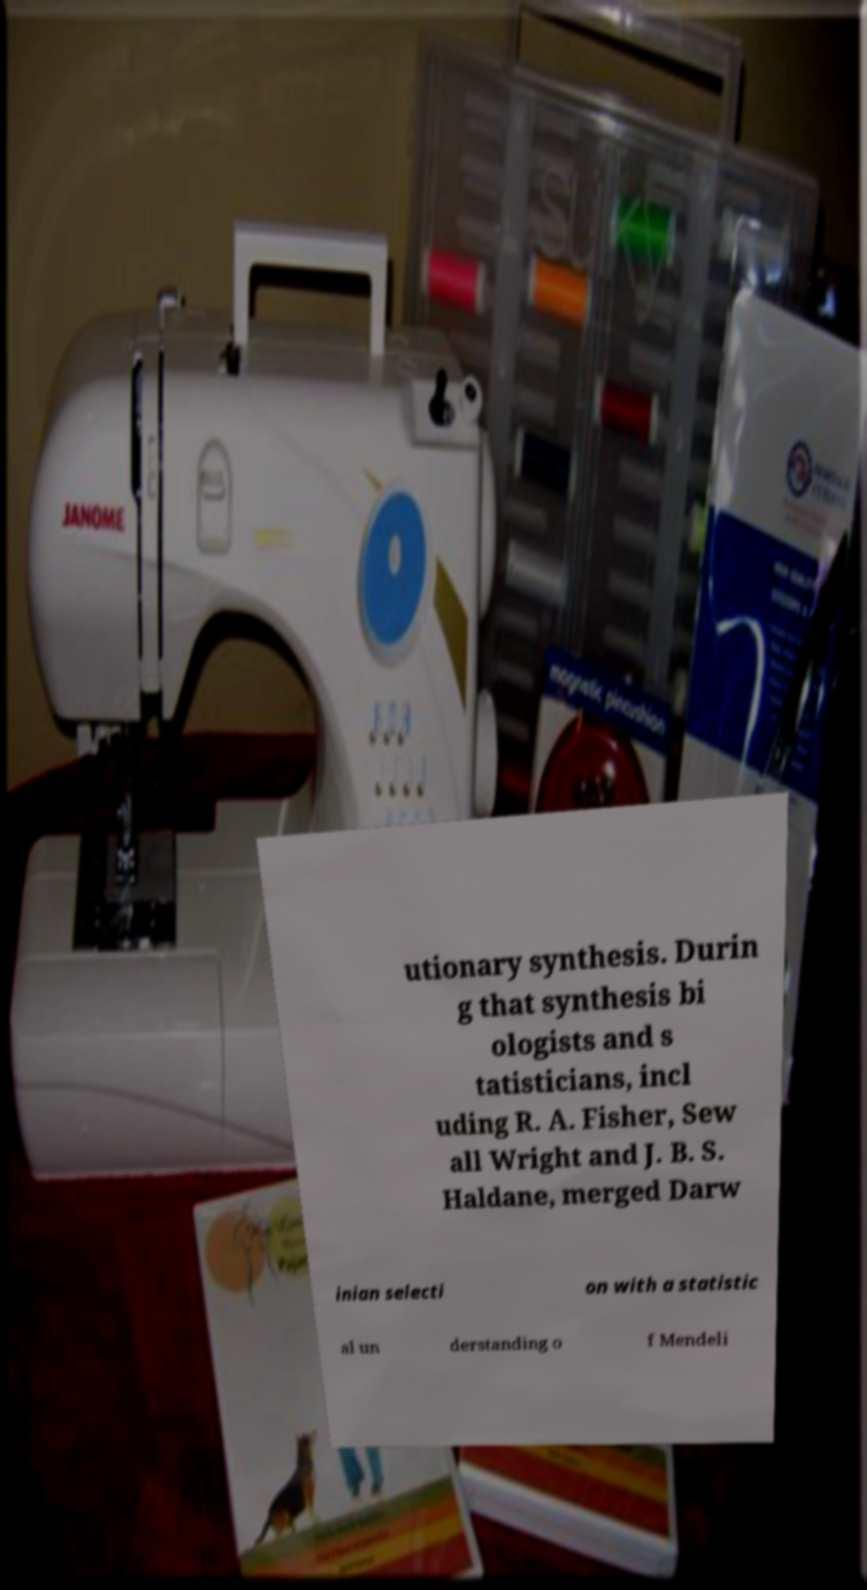Could you assist in decoding the text presented in this image and type it out clearly? utionary synthesis. Durin g that synthesis bi ologists and s tatisticians, incl uding R. A. Fisher, Sew all Wright and J. B. S. Haldane, merged Darw inian selecti on with a statistic al un derstanding o f Mendeli 